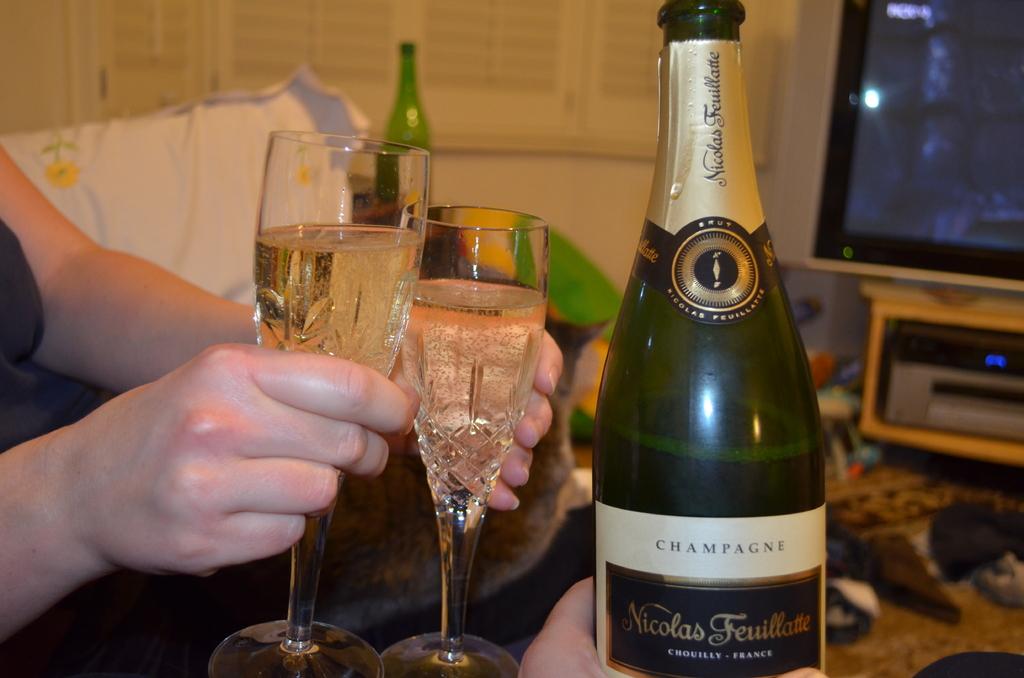What type of drink is in the bottle?
Your answer should be compact. Champagne. 